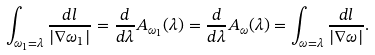Convert formula to latex. <formula><loc_0><loc_0><loc_500><loc_500>\int _ { \omega _ { 1 } = \lambda } \frac { d l } { | \nabla \omega _ { 1 } | } = \frac { d } { d \lambda } A _ { \omega _ { 1 } } ( \lambda ) = \frac { d } { d \lambda } A _ { \omega } ( \lambda ) = \int _ { \omega = \lambda } \frac { d l } { | \nabla \omega | } .</formula> 